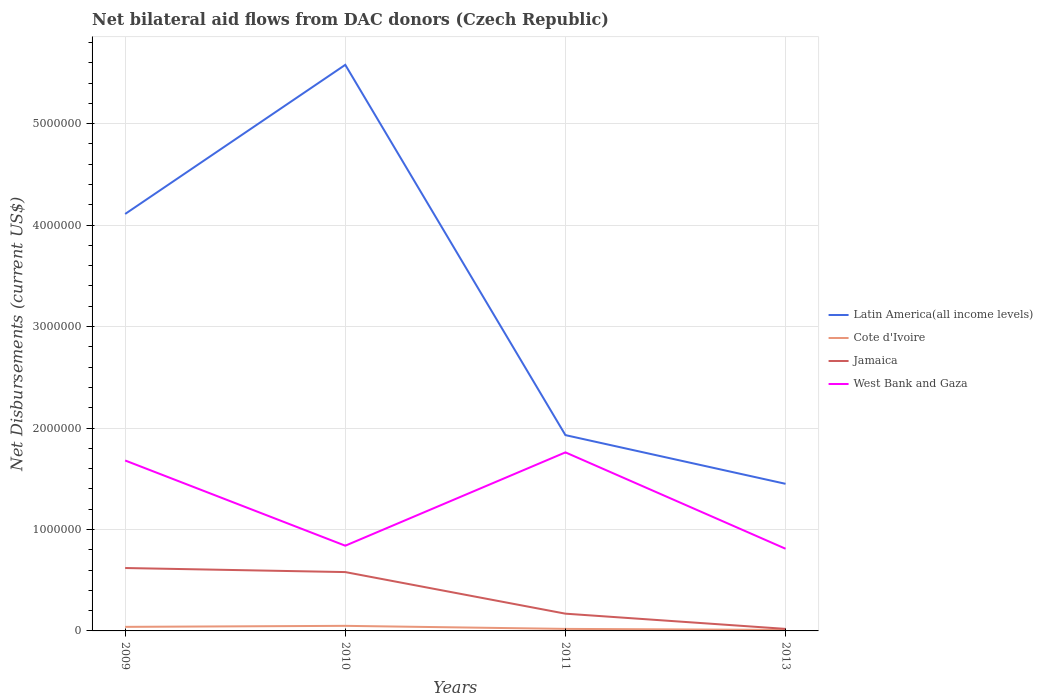How many different coloured lines are there?
Keep it short and to the point. 4. Does the line corresponding to Jamaica intersect with the line corresponding to West Bank and Gaza?
Your response must be concise. No. Is the number of lines equal to the number of legend labels?
Offer a terse response. Yes. Across all years, what is the maximum net bilateral aid flows in West Bank and Gaza?
Make the answer very short. 8.10e+05. What is the total net bilateral aid flows in Latin America(all income levels) in the graph?
Provide a short and direct response. 2.66e+06. What is the difference between the highest and the second highest net bilateral aid flows in Cote d'Ivoire?
Provide a short and direct response. 4.00e+04. Does the graph contain grids?
Give a very brief answer. Yes. How many legend labels are there?
Provide a succinct answer. 4. How are the legend labels stacked?
Offer a terse response. Vertical. What is the title of the graph?
Offer a terse response. Net bilateral aid flows from DAC donors (Czech Republic). What is the label or title of the Y-axis?
Ensure brevity in your answer.  Net Disbursements (current US$). What is the Net Disbursements (current US$) of Latin America(all income levels) in 2009?
Your answer should be compact. 4.11e+06. What is the Net Disbursements (current US$) in Cote d'Ivoire in 2009?
Keep it short and to the point. 4.00e+04. What is the Net Disbursements (current US$) in Jamaica in 2009?
Keep it short and to the point. 6.20e+05. What is the Net Disbursements (current US$) in West Bank and Gaza in 2009?
Ensure brevity in your answer.  1.68e+06. What is the Net Disbursements (current US$) in Latin America(all income levels) in 2010?
Give a very brief answer. 5.58e+06. What is the Net Disbursements (current US$) of Cote d'Ivoire in 2010?
Your answer should be compact. 5.00e+04. What is the Net Disbursements (current US$) of Jamaica in 2010?
Your answer should be compact. 5.80e+05. What is the Net Disbursements (current US$) of West Bank and Gaza in 2010?
Provide a short and direct response. 8.40e+05. What is the Net Disbursements (current US$) of Latin America(all income levels) in 2011?
Your answer should be compact. 1.93e+06. What is the Net Disbursements (current US$) in Cote d'Ivoire in 2011?
Your answer should be compact. 2.00e+04. What is the Net Disbursements (current US$) in West Bank and Gaza in 2011?
Your answer should be compact. 1.76e+06. What is the Net Disbursements (current US$) in Latin America(all income levels) in 2013?
Provide a short and direct response. 1.45e+06. What is the Net Disbursements (current US$) of Cote d'Ivoire in 2013?
Make the answer very short. 10000. What is the Net Disbursements (current US$) of West Bank and Gaza in 2013?
Offer a very short reply. 8.10e+05. Across all years, what is the maximum Net Disbursements (current US$) in Latin America(all income levels)?
Keep it short and to the point. 5.58e+06. Across all years, what is the maximum Net Disbursements (current US$) in Cote d'Ivoire?
Give a very brief answer. 5.00e+04. Across all years, what is the maximum Net Disbursements (current US$) of Jamaica?
Your answer should be compact. 6.20e+05. Across all years, what is the maximum Net Disbursements (current US$) of West Bank and Gaza?
Ensure brevity in your answer.  1.76e+06. Across all years, what is the minimum Net Disbursements (current US$) of Latin America(all income levels)?
Keep it short and to the point. 1.45e+06. Across all years, what is the minimum Net Disbursements (current US$) of Cote d'Ivoire?
Give a very brief answer. 10000. Across all years, what is the minimum Net Disbursements (current US$) of West Bank and Gaza?
Your response must be concise. 8.10e+05. What is the total Net Disbursements (current US$) of Latin America(all income levels) in the graph?
Ensure brevity in your answer.  1.31e+07. What is the total Net Disbursements (current US$) in Jamaica in the graph?
Offer a terse response. 1.39e+06. What is the total Net Disbursements (current US$) of West Bank and Gaza in the graph?
Provide a short and direct response. 5.09e+06. What is the difference between the Net Disbursements (current US$) of Latin America(all income levels) in 2009 and that in 2010?
Give a very brief answer. -1.47e+06. What is the difference between the Net Disbursements (current US$) of Jamaica in 2009 and that in 2010?
Your answer should be very brief. 4.00e+04. What is the difference between the Net Disbursements (current US$) of West Bank and Gaza in 2009 and that in 2010?
Give a very brief answer. 8.40e+05. What is the difference between the Net Disbursements (current US$) in Latin America(all income levels) in 2009 and that in 2011?
Provide a succinct answer. 2.18e+06. What is the difference between the Net Disbursements (current US$) in Latin America(all income levels) in 2009 and that in 2013?
Offer a terse response. 2.66e+06. What is the difference between the Net Disbursements (current US$) of Cote d'Ivoire in 2009 and that in 2013?
Offer a terse response. 3.00e+04. What is the difference between the Net Disbursements (current US$) in Jamaica in 2009 and that in 2013?
Provide a short and direct response. 6.00e+05. What is the difference between the Net Disbursements (current US$) in West Bank and Gaza in 2009 and that in 2013?
Your response must be concise. 8.70e+05. What is the difference between the Net Disbursements (current US$) of Latin America(all income levels) in 2010 and that in 2011?
Ensure brevity in your answer.  3.65e+06. What is the difference between the Net Disbursements (current US$) of Cote d'Ivoire in 2010 and that in 2011?
Your answer should be very brief. 3.00e+04. What is the difference between the Net Disbursements (current US$) in Jamaica in 2010 and that in 2011?
Offer a very short reply. 4.10e+05. What is the difference between the Net Disbursements (current US$) in West Bank and Gaza in 2010 and that in 2011?
Your answer should be compact. -9.20e+05. What is the difference between the Net Disbursements (current US$) of Latin America(all income levels) in 2010 and that in 2013?
Keep it short and to the point. 4.13e+06. What is the difference between the Net Disbursements (current US$) in Jamaica in 2010 and that in 2013?
Offer a terse response. 5.60e+05. What is the difference between the Net Disbursements (current US$) of Latin America(all income levels) in 2011 and that in 2013?
Your answer should be compact. 4.80e+05. What is the difference between the Net Disbursements (current US$) in Cote d'Ivoire in 2011 and that in 2013?
Keep it short and to the point. 10000. What is the difference between the Net Disbursements (current US$) of Jamaica in 2011 and that in 2013?
Ensure brevity in your answer.  1.50e+05. What is the difference between the Net Disbursements (current US$) of West Bank and Gaza in 2011 and that in 2013?
Your answer should be very brief. 9.50e+05. What is the difference between the Net Disbursements (current US$) in Latin America(all income levels) in 2009 and the Net Disbursements (current US$) in Cote d'Ivoire in 2010?
Your response must be concise. 4.06e+06. What is the difference between the Net Disbursements (current US$) of Latin America(all income levels) in 2009 and the Net Disbursements (current US$) of Jamaica in 2010?
Make the answer very short. 3.53e+06. What is the difference between the Net Disbursements (current US$) in Latin America(all income levels) in 2009 and the Net Disbursements (current US$) in West Bank and Gaza in 2010?
Your answer should be very brief. 3.27e+06. What is the difference between the Net Disbursements (current US$) in Cote d'Ivoire in 2009 and the Net Disbursements (current US$) in Jamaica in 2010?
Your answer should be compact. -5.40e+05. What is the difference between the Net Disbursements (current US$) in Cote d'Ivoire in 2009 and the Net Disbursements (current US$) in West Bank and Gaza in 2010?
Your response must be concise. -8.00e+05. What is the difference between the Net Disbursements (current US$) in Latin America(all income levels) in 2009 and the Net Disbursements (current US$) in Cote d'Ivoire in 2011?
Ensure brevity in your answer.  4.09e+06. What is the difference between the Net Disbursements (current US$) of Latin America(all income levels) in 2009 and the Net Disbursements (current US$) of Jamaica in 2011?
Offer a terse response. 3.94e+06. What is the difference between the Net Disbursements (current US$) of Latin America(all income levels) in 2009 and the Net Disbursements (current US$) of West Bank and Gaza in 2011?
Offer a terse response. 2.35e+06. What is the difference between the Net Disbursements (current US$) in Cote d'Ivoire in 2009 and the Net Disbursements (current US$) in Jamaica in 2011?
Your response must be concise. -1.30e+05. What is the difference between the Net Disbursements (current US$) of Cote d'Ivoire in 2009 and the Net Disbursements (current US$) of West Bank and Gaza in 2011?
Make the answer very short. -1.72e+06. What is the difference between the Net Disbursements (current US$) in Jamaica in 2009 and the Net Disbursements (current US$) in West Bank and Gaza in 2011?
Offer a terse response. -1.14e+06. What is the difference between the Net Disbursements (current US$) in Latin America(all income levels) in 2009 and the Net Disbursements (current US$) in Cote d'Ivoire in 2013?
Provide a short and direct response. 4.10e+06. What is the difference between the Net Disbursements (current US$) in Latin America(all income levels) in 2009 and the Net Disbursements (current US$) in Jamaica in 2013?
Keep it short and to the point. 4.09e+06. What is the difference between the Net Disbursements (current US$) of Latin America(all income levels) in 2009 and the Net Disbursements (current US$) of West Bank and Gaza in 2013?
Your answer should be very brief. 3.30e+06. What is the difference between the Net Disbursements (current US$) of Cote d'Ivoire in 2009 and the Net Disbursements (current US$) of Jamaica in 2013?
Provide a succinct answer. 2.00e+04. What is the difference between the Net Disbursements (current US$) in Cote d'Ivoire in 2009 and the Net Disbursements (current US$) in West Bank and Gaza in 2013?
Offer a terse response. -7.70e+05. What is the difference between the Net Disbursements (current US$) in Latin America(all income levels) in 2010 and the Net Disbursements (current US$) in Cote d'Ivoire in 2011?
Give a very brief answer. 5.56e+06. What is the difference between the Net Disbursements (current US$) of Latin America(all income levels) in 2010 and the Net Disbursements (current US$) of Jamaica in 2011?
Your answer should be compact. 5.41e+06. What is the difference between the Net Disbursements (current US$) in Latin America(all income levels) in 2010 and the Net Disbursements (current US$) in West Bank and Gaza in 2011?
Provide a succinct answer. 3.82e+06. What is the difference between the Net Disbursements (current US$) in Cote d'Ivoire in 2010 and the Net Disbursements (current US$) in West Bank and Gaza in 2011?
Provide a short and direct response. -1.71e+06. What is the difference between the Net Disbursements (current US$) of Jamaica in 2010 and the Net Disbursements (current US$) of West Bank and Gaza in 2011?
Offer a very short reply. -1.18e+06. What is the difference between the Net Disbursements (current US$) of Latin America(all income levels) in 2010 and the Net Disbursements (current US$) of Cote d'Ivoire in 2013?
Offer a terse response. 5.57e+06. What is the difference between the Net Disbursements (current US$) of Latin America(all income levels) in 2010 and the Net Disbursements (current US$) of Jamaica in 2013?
Give a very brief answer. 5.56e+06. What is the difference between the Net Disbursements (current US$) of Latin America(all income levels) in 2010 and the Net Disbursements (current US$) of West Bank and Gaza in 2013?
Offer a very short reply. 4.77e+06. What is the difference between the Net Disbursements (current US$) of Cote d'Ivoire in 2010 and the Net Disbursements (current US$) of Jamaica in 2013?
Keep it short and to the point. 3.00e+04. What is the difference between the Net Disbursements (current US$) of Cote d'Ivoire in 2010 and the Net Disbursements (current US$) of West Bank and Gaza in 2013?
Offer a terse response. -7.60e+05. What is the difference between the Net Disbursements (current US$) of Latin America(all income levels) in 2011 and the Net Disbursements (current US$) of Cote d'Ivoire in 2013?
Provide a succinct answer. 1.92e+06. What is the difference between the Net Disbursements (current US$) in Latin America(all income levels) in 2011 and the Net Disbursements (current US$) in Jamaica in 2013?
Your answer should be very brief. 1.91e+06. What is the difference between the Net Disbursements (current US$) in Latin America(all income levels) in 2011 and the Net Disbursements (current US$) in West Bank and Gaza in 2013?
Your response must be concise. 1.12e+06. What is the difference between the Net Disbursements (current US$) in Cote d'Ivoire in 2011 and the Net Disbursements (current US$) in Jamaica in 2013?
Provide a short and direct response. 0. What is the difference between the Net Disbursements (current US$) of Cote d'Ivoire in 2011 and the Net Disbursements (current US$) of West Bank and Gaza in 2013?
Your response must be concise. -7.90e+05. What is the difference between the Net Disbursements (current US$) of Jamaica in 2011 and the Net Disbursements (current US$) of West Bank and Gaza in 2013?
Make the answer very short. -6.40e+05. What is the average Net Disbursements (current US$) in Latin America(all income levels) per year?
Ensure brevity in your answer.  3.27e+06. What is the average Net Disbursements (current US$) in Cote d'Ivoire per year?
Provide a short and direct response. 3.00e+04. What is the average Net Disbursements (current US$) of Jamaica per year?
Make the answer very short. 3.48e+05. What is the average Net Disbursements (current US$) of West Bank and Gaza per year?
Make the answer very short. 1.27e+06. In the year 2009, what is the difference between the Net Disbursements (current US$) in Latin America(all income levels) and Net Disbursements (current US$) in Cote d'Ivoire?
Ensure brevity in your answer.  4.07e+06. In the year 2009, what is the difference between the Net Disbursements (current US$) of Latin America(all income levels) and Net Disbursements (current US$) of Jamaica?
Provide a short and direct response. 3.49e+06. In the year 2009, what is the difference between the Net Disbursements (current US$) in Latin America(all income levels) and Net Disbursements (current US$) in West Bank and Gaza?
Ensure brevity in your answer.  2.43e+06. In the year 2009, what is the difference between the Net Disbursements (current US$) in Cote d'Ivoire and Net Disbursements (current US$) in Jamaica?
Offer a very short reply. -5.80e+05. In the year 2009, what is the difference between the Net Disbursements (current US$) in Cote d'Ivoire and Net Disbursements (current US$) in West Bank and Gaza?
Offer a terse response. -1.64e+06. In the year 2009, what is the difference between the Net Disbursements (current US$) in Jamaica and Net Disbursements (current US$) in West Bank and Gaza?
Your answer should be very brief. -1.06e+06. In the year 2010, what is the difference between the Net Disbursements (current US$) in Latin America(all income levels) and Net Disbursements (current US$) in Cote d'Ivoire?
Give a very brief answer. 5.53e+06. In the year 2010, what is the difference between the Net Disbursements (current US$) in Latin America(all income levels) and Net Disbursements (current US$) in West Bank and Gaza?
Your response must be concise. 4.74e+06. In the year 2010, what is the difference between the Net Disbursements (current US$) of Cote d'Ivoire and Net Disbursements (current US$) of Jamaica?
Keep it short and to the point. -5.30e+05. In the year 2010, what is the difference between the Net Disbursements (current US$) in Cote d'Ivoire and Net Disbursements (current US$) in West Bank and Gaza?
Keep it short and to the point. -7.90e+05. In the year 2011, what is the difference between the Net Disbursements (current US$) of Latin America(all income levels) and Net Disbursements (current US$) of Cote d'Ivoire?
Provide a succinct answer. 1.91e+06. In the year 2011, what is the difference between the Net Disbursements (current US$) in Latin America(all income levels) and Net Disbursements (current US$) in Jamaica?
Your answer should be very brief. 1.76e+06. In the year 2011, what is the difference between the Net Disbursements (current US$) in Cote d'Ivoire and Net Disbursements (current US$) in Jamaica?
Your answer should be very brief. -1.50e+05. In the year 2011, what is the difference between the Net Disbursements (current US$) of Cote d'Ivoire and Net Disbursements (current US$) of West Bank and Gaza?
Your response must be concise. -1.74e+06. In the year 2011, what is the difference between the Net Disbursements (current US$) in Jamaica and Net Disbursements (current US$) in West Bank and Gaza?
Provide a succinct answer. -1.59e+06. In the year 2013, what is the difference between the Net Disbursements (current US$) in Latin America(all income levels) and Net Disbursements (current US$) in Cote d'Ivoire?
Offer a very short reply. 1.44e+06. In the year 2013, what is the difference between the Net Disbursements (current US$) in Latin America(all income levels) and Net Disbursements (current US$) in Jamaica?
Your response must be concise. 1.43e+06. In the year 2013, what is the difference between the Net Disbursements (current US$) of Latin America(all income levels) and Net Disbursements (current US$) of West Bank and Gaza?
Make the answer very short. 6.40e+05. In the year 2013, what is the difference between the Net Disbursements (current US$) in Cote d'Ivoire and Net Disbursements (current US$) in Jamaica?
Offer a terse response. -10000. In the year 2013, what is the difference between the Net Disbursements (current US$) in Cote d'Ivoire and Net Disbursements (current US$) in West Bank and Gaza?
Offer a very short reply. -8.00e+05. In the year 2013, what is the difference between the Net Disbursements (current US$) in Jamaica and Net Disbursements (current US$) in West Bank and Gaza?
Provide a short and direct response. -7.90e+05. What is the ratio of the Net Disbursements (current US$) in Latin America(all income levels) in 2009 to that in 2010?
Provide a succinct answer. 0.74. What is the ratio of the Net Disbursements (current US$) of Jamaica in 2009 to that in 2010?
Offer a terse response. 1.07. What is the ratio of the Net Disbursements (current US$) in Latin America(all income levels) in 2009 to that in 2011?
Provide a succinct answer. 2.13. What is the ratio of the Net Disbursements (current US$) in Jamaica in 2009 to that in 2011?
Offer a very short reply. 3.65. What is the ratio of the Net Disbursements (current US$) in West Bank and Gaza in 2009 to that in 2011?
Make the answer very short. 0.95. What is the ratio of the Net Disbursements (current US$) of Latin America(all income levels) in 2009 to that in 2013?
Your answer should be very brief. 2.83. What is the ratio of the Net Disbursements (current US$) of Cote d'Ivoire in 2009 to that in 2013?
Ensure brevity in your answer.  4. What is the ratio of the Net Disbursements (current US$) in Jamaica in 2009 to that in 2013?
Your answer should be compact. 31. What is the ratio of the Net Disbursements (current US$) in West Bank and Gaza in 2009 to that in 2013?
Make the answer very short. 2.07. What is the ratio of the Net Disbursements (current US$) of Latin America(all income levels) in 2010 to that in 2011?
Make the answer very short. 2.89. What is the ratio of the Net Disbursements (current US$) in Cote d'Ivoire in 2010 to that in 2011?
Keep it short and to the point. 2.5. What is the ratio of the Net Disbursements (current US$) in Jamaica in 2010 to that in 2011?
Offer a very short reply. 3.41. What is the ratio of the Net Disbursements (current US$) of West Bank and Gaza in 2010 to that in 2011?
Your response must be concise. 0.48. What is the ratio of the Net Disbursements (current US$) of Latin America(all income levels) in 2010 to that in 2013?
Your answer should be very brief. 3.85. What is the ratio of the Net Disbursements (current US$) in Cote d'Ivoire in 2010 to that in 2013?
Provide a short and direct response. 5. What is the ratio of the Net Disbursements (current US$) in Jamaica in 2010 to that in 2013?
Give a very brief answer. 29. What is the ratio of the Net Disbursements (current US$) in West Bank and Gaza in 2010 to that in 2013?
Offer a very short reply. 1.04. What is the ratio of the Net Disbursements (current US$) in Latin America(all income levels) in 2011 to that in 2013?
Provide a short and direct response. 1.33. What is the ratio of the Net Disbursements (current US$) of Cote d'Ivoire in 2011 to that in 2013?
Make the answer very short. 2. What is the ratio of the Net Disbursements (current US$) in Jamaica in 2011 to that in 2013?
Your response must be concise. 8.5. What is the ratio of the Net Disbursements (current US$) in West Bank and Gaza in 2011 to that in 2013?
Keep it short and to the point. 2.17. What is the difference between the highest and the second highest Net Disbursements (current US$) in Latin America(all income levels)?
Offer a terse response. 1.47e+06. What is the difference between the highest and the second highest Net Disbursements (current US$) in Cote d'Ivoire?
Make the answer very short. 10000. What is the difference between the highest and the second highest Net Disbursements (current US$) in Jamaica?
Offer a terse response. 4.00e+04. What is the difference between the highest and the second highest Net Disbursements (current US$) in West Bank and Gaza?
Your answer should be compact. 8.00e+04. What is the difference between the highest and the lowest Net Disbursements (current US$) of Latin America(all income levels)?
Keep it short and to the point. 4.13e+06. What is the difference between the highest and the lowest Net Disbursements (current US$) of Jamaica?
Keep it short and to the point. 6.00e+05. What is the difference between the highest and the lowest Net Disbursements (current US$) in West Bank and Gaza?
Your answer should be very brief. 9.50e+05. 